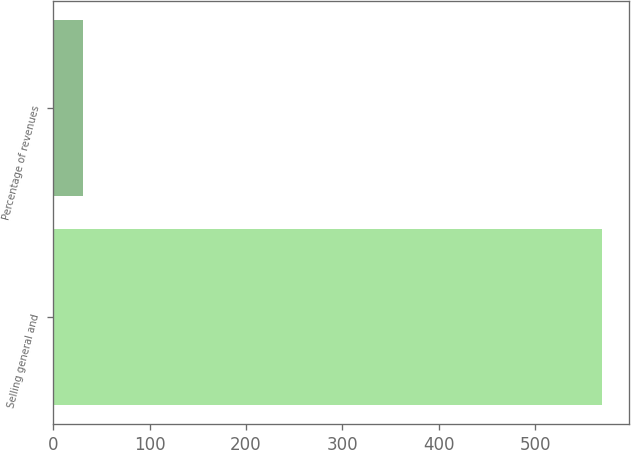Convert chart to OTSL. <chart><loc_0><loc_0><loc_500><loc_500><bar_chart><fcel>Selling general and<fcel>Percentage of revenues<nl><fcel>569<fcel>31.4<nl></chart> 